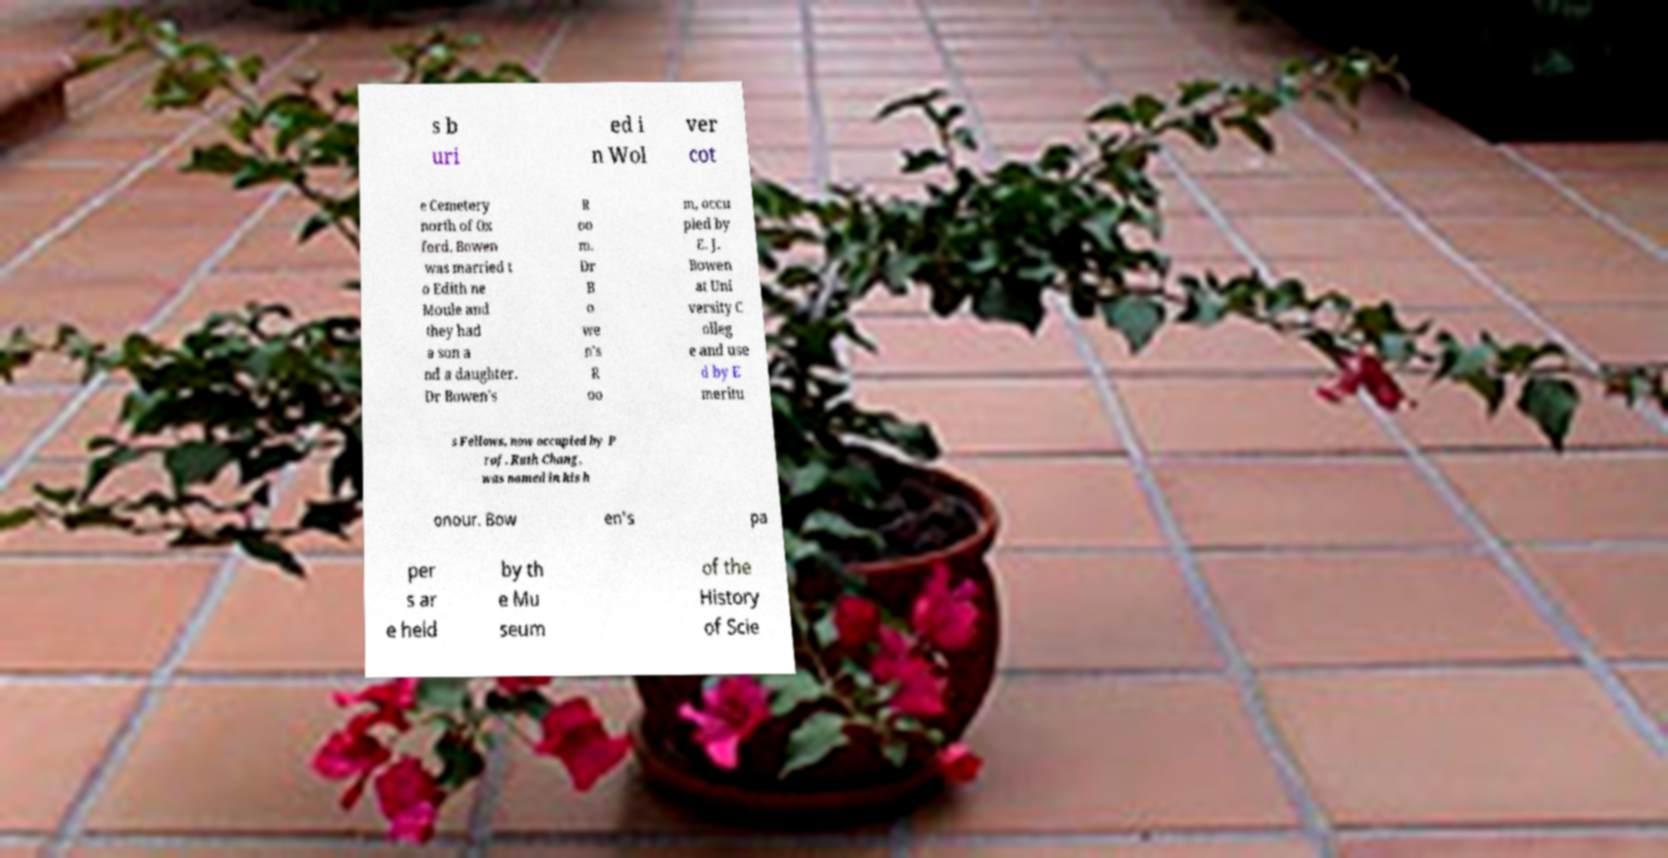There's text embedded in this image that I need extracted. Can you transcribe it verbatim? s b uri ed i n Wol ver cot e Cemetery north of Ox ford. Bowen was married t o Edith ne Moule and they had a son a nd a daughter. Dr Bowen's R oo m. Dr B o we n's R oo m, occu pied by E. J. Bowen at Uni versity C olleg e and use d by E meritu s Fellows, now occupied by P rof. Ruth Chang, was named in his h onour. Bow en's pa per s ar e held by th e Mu seum of the History of Scie 